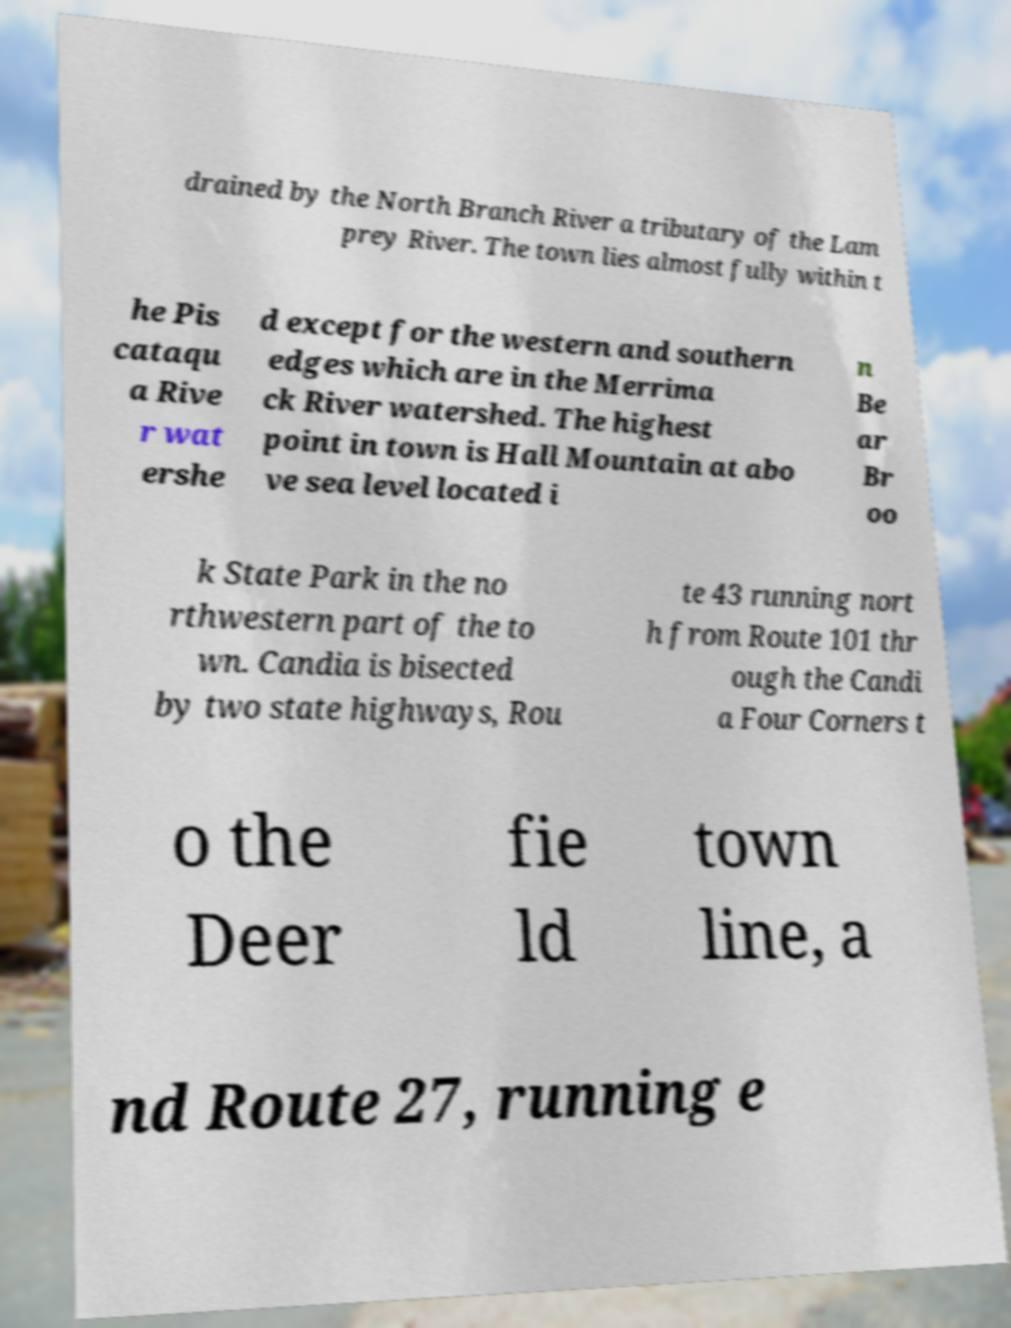Please identify and transcribe the text found in this image. drained by the North Branch River a tributary of the Lam prey River. The town lies almost fully within t he Pis cataqu a Rive r wat ershe d except for the western and southern edges which are in the Merrima ck River watershed. The highest point in town is Hall Mountain at abo ve sea level located i n Be ar Br oo k State Park in the no rthwestern part of the to wn. Candia is bisected by two state highways, Rou te 43 running nort h from Route 101 thr ough the Candi a Four Corners t o the Deer fie ld town line, a nd Route 27, running e 